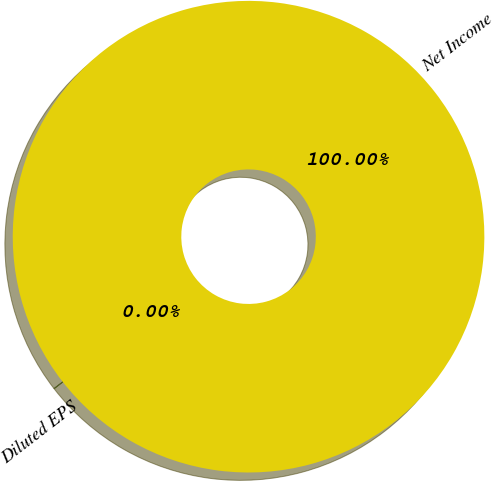<chart> <loc_0><loc_0><loc_500><loc_500><pie_chart><fcel>Net Income<fcel>Diluted EPS<nl><fcel>100.0%<fcel>0.0%<nl></chart> 